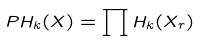<formula> <loc_0><loc_0><loc_500><loc_500>P H _ { k } ( X ) = \prod H _ { k } ( X _ { r } )</formula> 